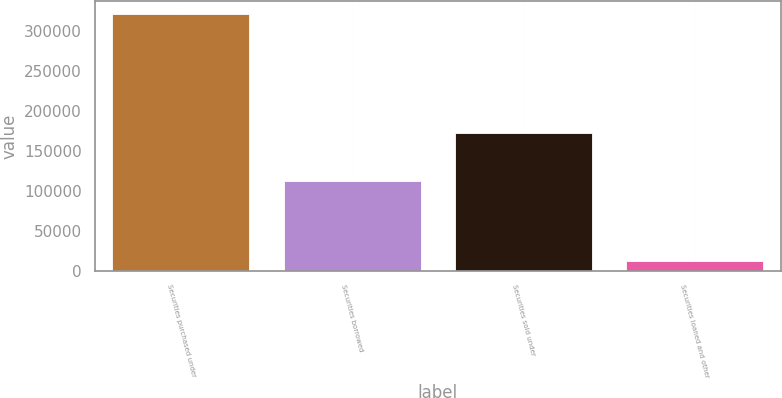Convert chart. <chart><loc_0><loc_0><loc_500><loc_500><bar_chart><fcel>Securities purchased under<fcel>Securities borrowed<fcel>Securities sold under<fcel>Securities loaned and other<nl><fcel>321504<fcel>111995<fcel>171975<fcel>12740<nl></chart> 